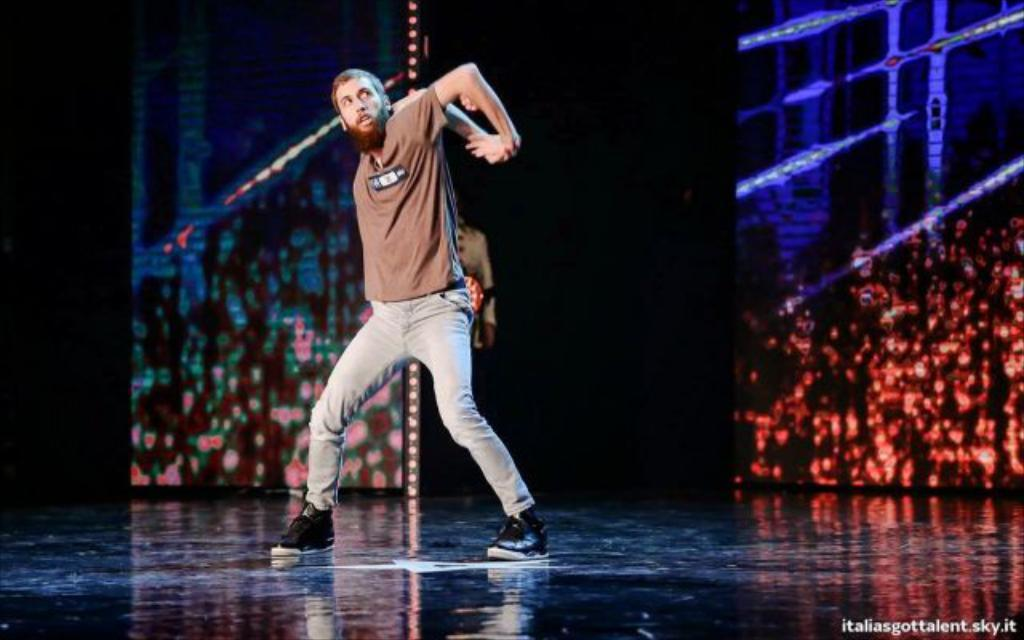What is the main subject in the middle of the image? There is a man standing in the middle of the image. What can be seen on the right side of the image? There is a screen on the right side of the image. How would you describe the overall lighting in the image? The background of the image is dark. Where is the text located in the image? There is some text at the bottom right corner of the image. What type of growth can be seen on the bushes in the image? There are no bushes present in the image, so it is not possible to determine the type of growth on any bushes. 